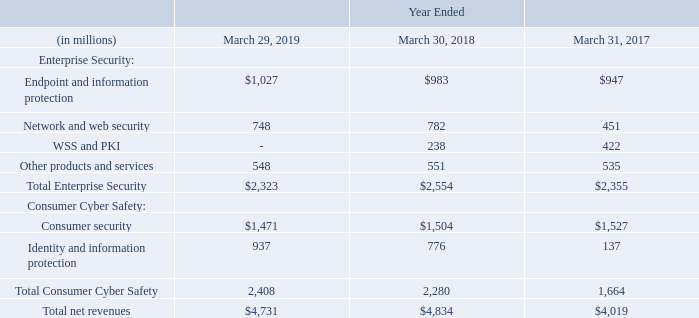The following table summarizes net revenues by significant product and services categories:
Endpoint and information protection products include endpoint security, advanced threat protection, and information protection solutions and their related support services. Network and web security products include network security, web security, and cloud security solutions and their related support services. WSS and PKI products consist of the solutions we divested on October 31, 2017. Other products and services primarily consist of email security products, managed security services, consulting, and other professional services.
Consumer security products include Norton security, Norton Secure VPN, and other consumer security solutions. Identity and information protection products include LifeLock identity theft protection and other information protection solutions.
Products and service revenue information
What do Endpoint and information protection products include? Endpoint security, advanced threat protection, and information protection solutions and their related support services. What does Consumer security products include? Norton security, norton secure vpn, and other consumer security solutions. What is the Total net revenues for year ended march 29, 2019?
Answer scale should be: million. $4,731. For year ended march 29, 2019, what is Total Enterprise Security expressed as a percentage of Total net revenues?
Answer scale should be: percent. 2,323/4,731
Answer: 49.1. What is the average Total net revenues for the fiscal years 2019, 2018 and 2017?
Answer scale should be: million. (4,731+4,834+4,019)/3
Answer: 4528. For year ended march 29, 2019, what is the difference between  Total Consumer Cyber Safety and Total Enterprise Security?
Answer scale should be: million. 2,408-2,323
Answer: 85. 